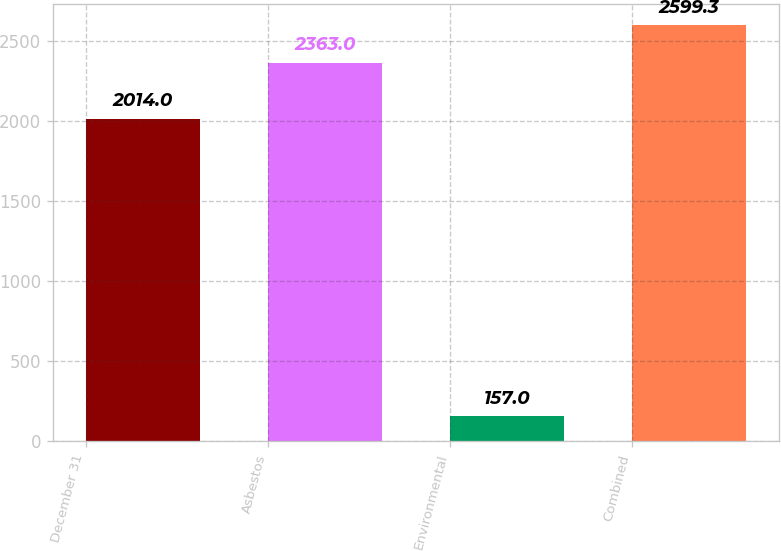Convert chart to OTSL. <chart><loc_0><loc_0><loc_500><loc_500><bar_chart><fcel>December 31<fcel>Asbestos<fcel>Environmental<fcel>Combined<nl><fcel>2014<fcel>2363<fcel>157<fcel>2599.3<nl></chart> 